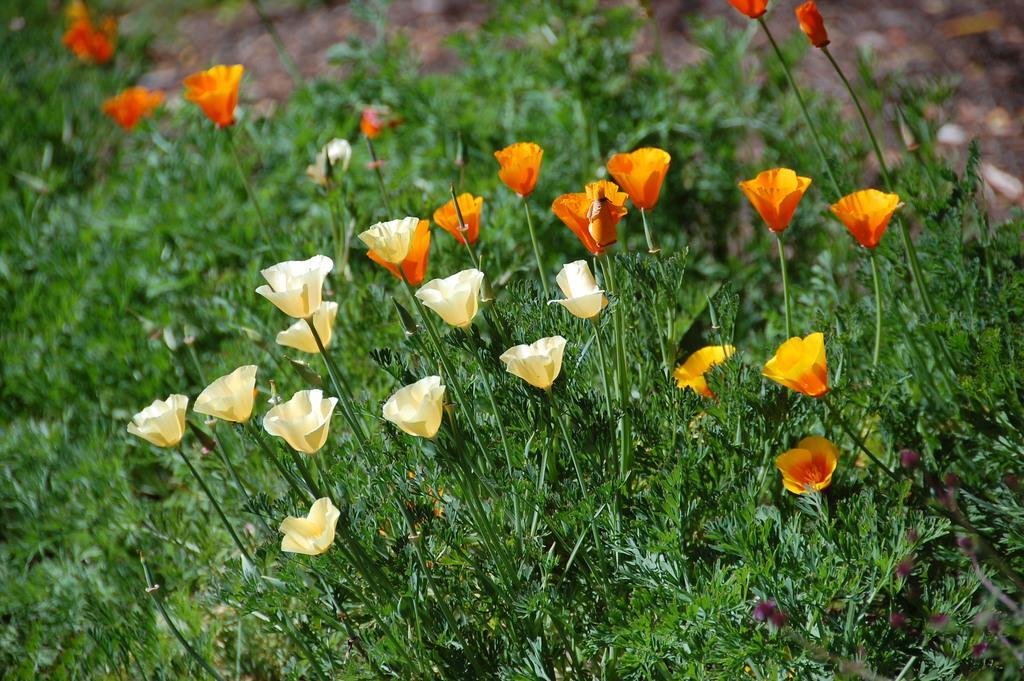Please provide a concise description of this image. In the picture there are some plants and there are beautiful flowers to the plants. 